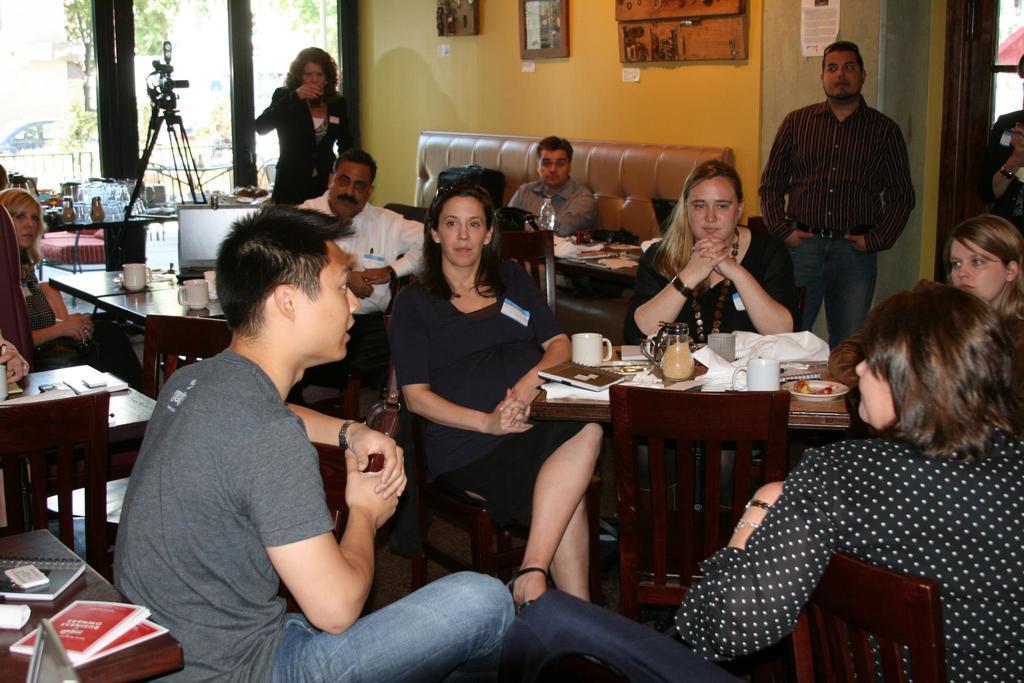In one or two sentences, can you explain what this image depicts? In this picture we can see a group of people where some are sitting on chairs and some are standing and in front of them there is table and on table we can see cup, book, jug, papers, plate with food in it, bottle, laptop and in background we can see camera on stand, windows, trees, fence, wall with frames. 